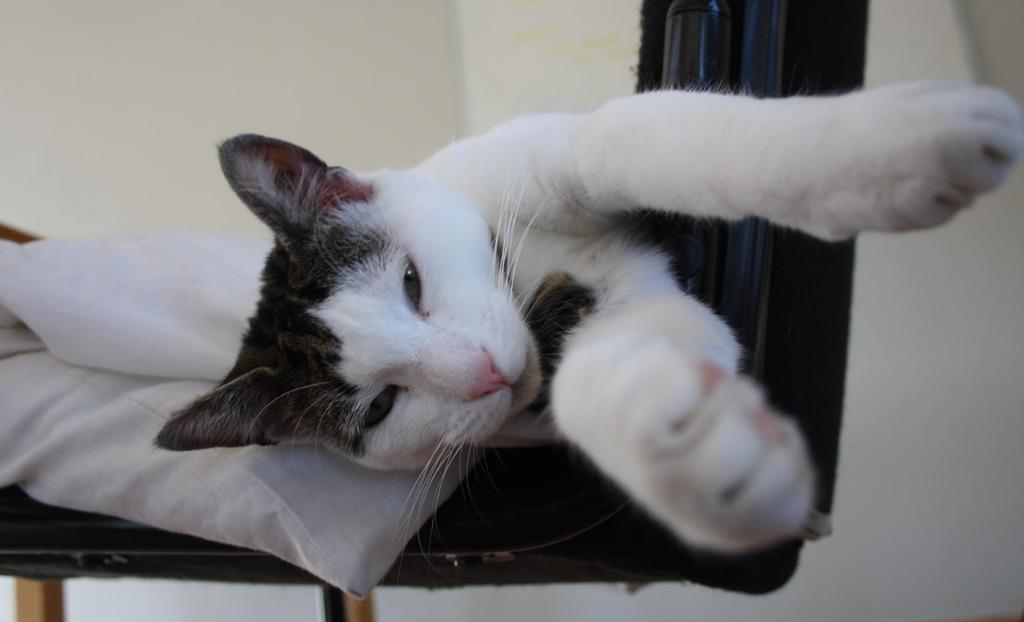What type of chair is in the image? There is a black color chair in the image. What is on the chair in the image? There is a pillow placed on the chair, and a cat is on the pillow. What can be seen in the background of the image? There is a plain wall in the background of the image. Can you hear the servant whistling in the image? There is no servant or whistling present in the image. 